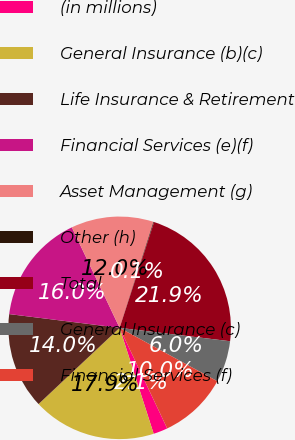Convert chart. <chart><loc_0><loc_0><loc_500><loc_500><pie_chart><fcel>(in millions)<fcel>General Insurance (b)(c)<fcel>Life Insurance & Retirement<fcel>Financial Services (e)(f)<fcel>Asset Management (g)<fcel>Other (h)<fcel>Total<fcel>General Insurance (c)<fcel>Financial Services (f)<nl><fcel>2.08%<fcel>17.94%<fcel>13.98%<fcel>15.96%<fcel>11.99%<fcel>0.09%<fcel>21.91%<fcel>6.04%<fcel>10.01%<nl></chart> 